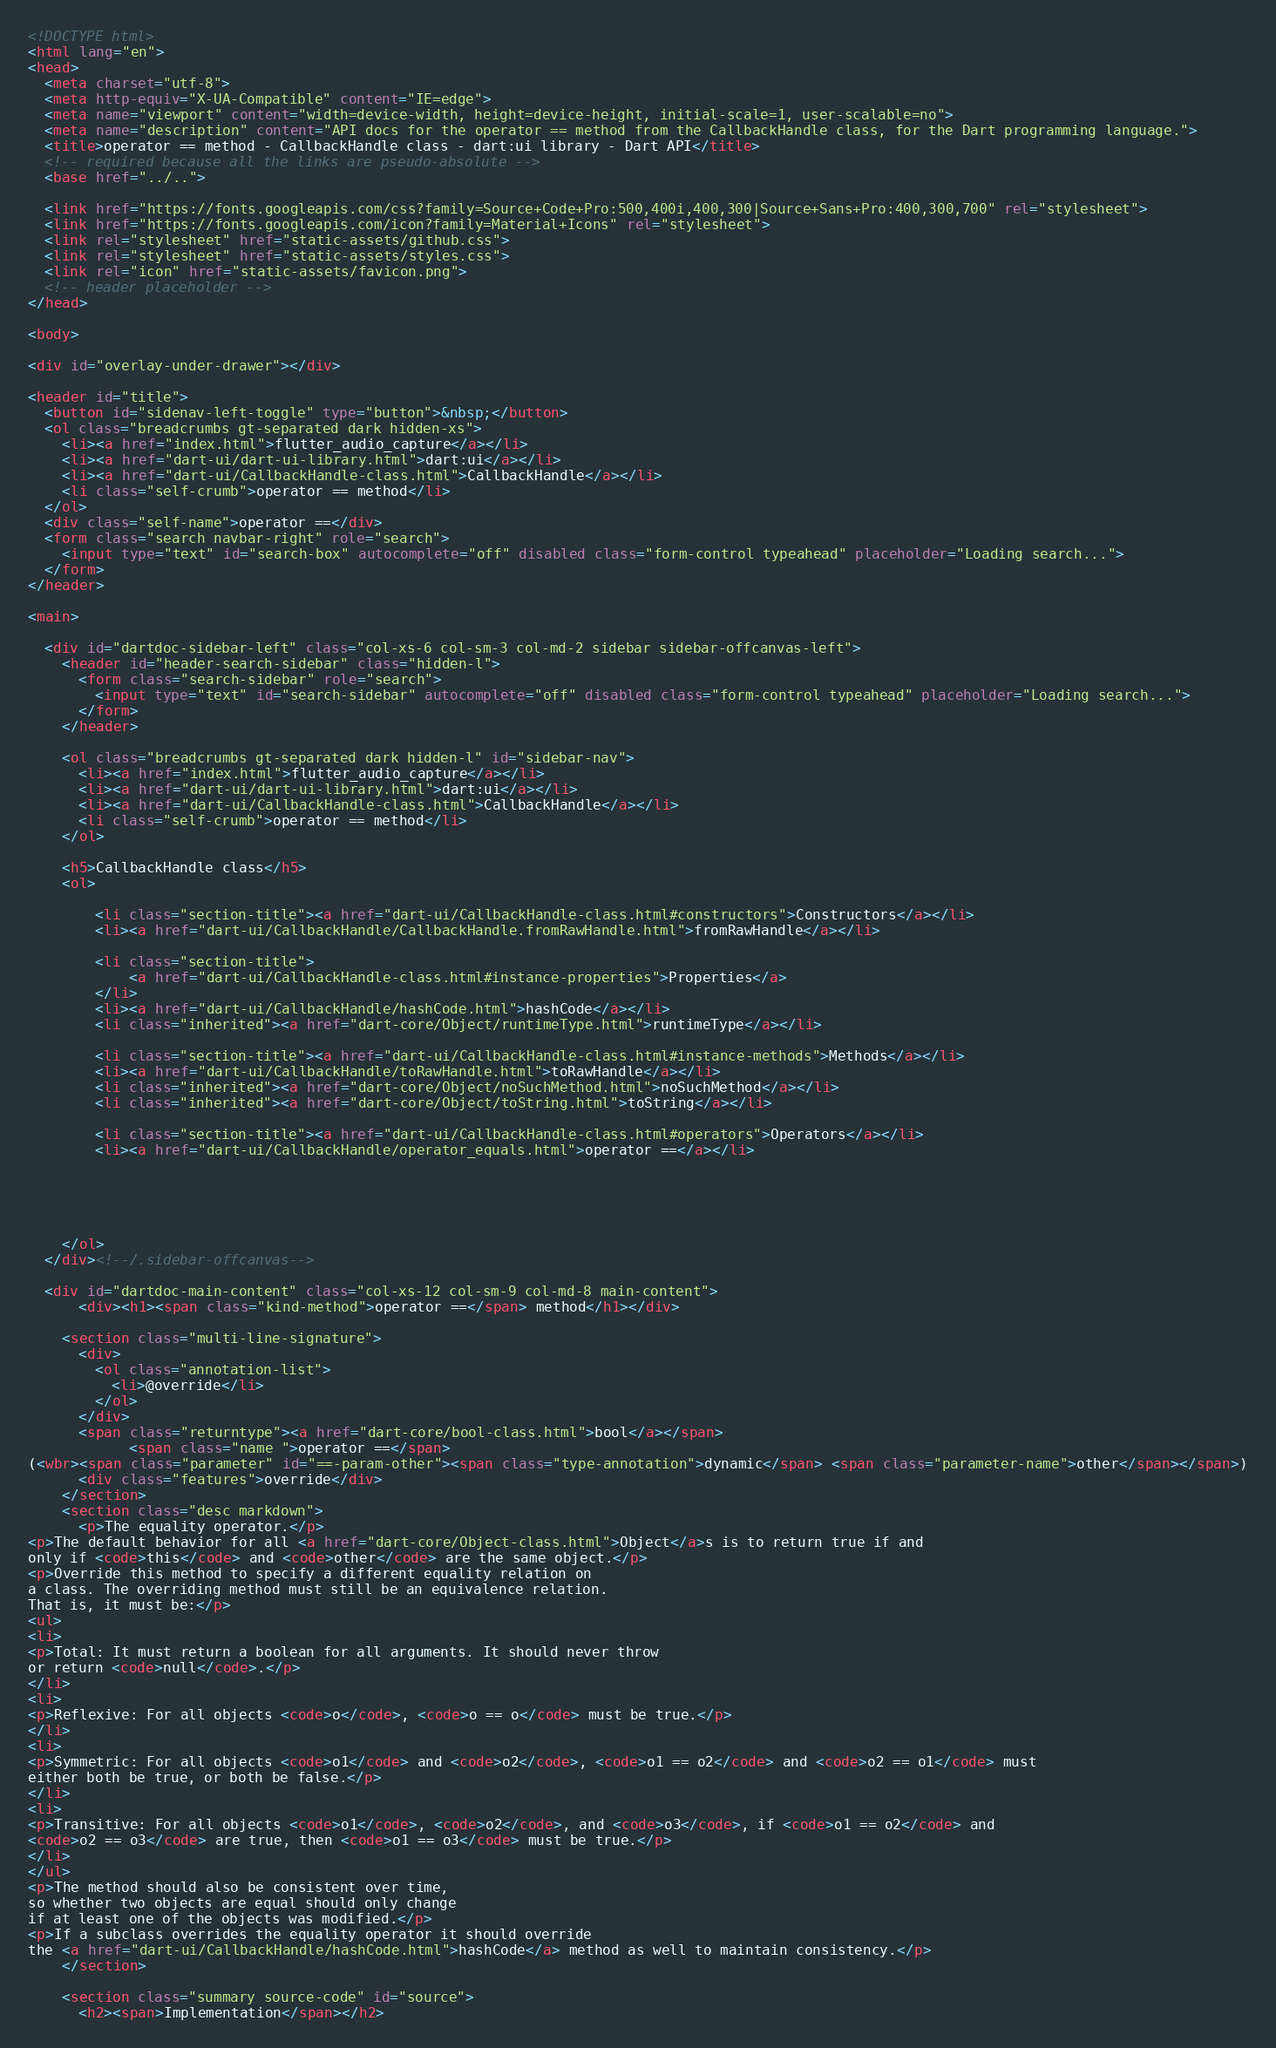<code> <loc_0><loc_0><loc_500><loc_500><_HTML_><!DOCTYPE html>
<html lang="en">
<head>
  <meta charset="utf-8">
  <meta http-equiv="X-UA-Compatible" content="IE=edge">
  <meta name="viewport" content="width=device-width, height=device-height, initial-scale=1, user-scalable=no">
  <meta name="description" content="API docs for the operator == method from the CallbackHandle class, for the Dart programming language.">
  <title>operator == method - CallbackHandle class - dart:ui library - Dart API</title>
  <!-- required because all the links are pseudo-absolute -->
  <base href="../..">

  <link href="https://fonts.googleapis.com/css?family=Source+Code+Pro:500,400i,400,300|Source+Sans+Pro:400,300,700" rel="stylesheet">
  <link href="https://fonts.googleapis.com/icon?family=Material+Icons" rel="stylesheet">
  <link rel="stylesheet" href="static-assets/github.css">
  <link rel="stylesheet" href="static-assets/styles.css">
  <link rel="icon" href="static-assets/favicon.png">
  <!-- header placeholder -->
</head>

<body>

<div id="overlay-under-drawer"></div>

<header id="title">
  <button id="sidenav-left-toggle" type="button">&nbsp;</button>
  <ol class="breadcrumbs gt-separated dark hidden-xs">
    <li><a href="index.html">flutter_audio_capture</a></li>
    <li><a href="dart-ui/dart-ui-library.html">dart:ui</a></li>
    <li><a href="dart-ui/CallbackHandle-class.html">CallbackHandle</a></li>
    <li class="self-crumb">operator == method</li>
  </ol>
  <div class="self-name">operator ==</div>
  <form class="search navbar-right" role="search">
    <input type="text" id="search-box" autocomplete="off" disabled class="form-control typeahead" placeholder="Loading search...">
  </form>
</header>

<main>

  <div id="dartdoc-sidebar-left" class="col-xs-6 col-sm-3 col-md-2 sidebar sidebar-offcanvas-left">
    <header id="header-search-sidebar" class="hidden-l">
      <form class="search-sidebar" role="search">
        <input type="text" id="search-sidebar" autocomplete="off" disabled class="form-control typeahead" placeholder="Loading search...">
      </form>
    </header>
    
    <ol class="breadcrumbs gt-separated dark hidden-l" id="sidebar-nav">
      <li><a href="index.html">flutter_audio_capture</a></li>
      <li><a href="dart-ui/dart-ui-library.html">dart:ui</a></li>
      <li><a href="dart-ui/CallbackHandle-class.html">CallbackHandle</a></li>
      <li class="self-crumb">operator == method</li>
    </ol>
    
    <h5>CallbackHandle class</h5>
    <ol>
    
        <li class="section-title"><a href="dart-ui/CallbackHandle-class.html#constructors">Constructors</a></li>
        <li><a href="dart-ui/CallbackHandle/CallbackHandle.fromRawHandle.html">fromRawHandle</a></li>
    
        <li class="section-title">
            <a href="dart-ui/CallbackHandle-class.html#instance-properties">Properties</a>
        </li>
        <li><a href="dart-ui/CallbackHandle/hashCode.html">hashCode</a></li>
        <li class="inherited"><a href="dart-core/Object/runtimeType.html">runtimeType</a></li>
    
        <li class="section-title"><a href="dart-ui/CallbackHandle-class.html#instance-methods">Methods</a></li>
        <li><a href="dart-ui/CallbackHandle/toRawHandle.html">toRawHandle</a></li>
        <li class="inherited"><a href="dart-core/Object/noSuchMethod.html">noSuchMethod</a></li>
        <li class="inherited"><a href="dart-core/Object/toString.html">toString</a></li>
    
        <li class="section-title"><a href="dart-ui/CallbackHandle-class.html#operators">Operators</a></li>
        <li><a href="dart-ui/CallbackHandle/operator_equals.html">operator ==</a></li>
    
    
    
    
    
    </ol>
  </div><!--/.sidebar-offcanvas-->

  <div id="dartdoc-main-content" class="col-xs-12 col-sm-9 col-md-8 main-content">
      <div><h1><span class="kind-method">operator ==</span> method</h1></div>

    <section class="multi-line-signature">
      <div>
        <ol class="annotation-list">
          <li>@override</li>
        </ol>
      </div>
      <span class="returntype"><a href="dart-core/bool-class.html">bool</a></span>
            <span class="name ">operator ==</span>
(<wbr><span class="parameter" id="==-param-other"><span class="type-annotation">dynamic</span> <span class="parameter-name">other</span></span>)
      <div class="features">override</div>
    </section>
    <section class="desc markdown">
      <p>The equality operator.</p>
<p>The default behavior for all <a href="dart-core/Object-class.html">Object</a>s is to return true if and
only if <code>this</code> and <code>other</code> are the same object.</p>
<p>Override this method to specify a different equality relation on
a class. The overriding method must still be an equivalence relation.
That is, it must be:</p>
<ul>
<li>
<p>Total: It must return a boolean for all arguments. It should never throw
or return <code>null</code>.</p>
</li>
<li>
<p>Reflexive: For all objects <code>o</code>, <code>o == o</code> must be true.</p>
</li>
<li>
<p>Symmetric: For all objects <code>o1</code> and <code>o2</code>, <code>o1 == o2</code> and <code>o2 == o1</code> must
either both be true, or both be false.</p>
</li>
<li>
<p>Transitive: For all objects <code>o1</code>, <code>o2</code>, and <code>o3</code>, if <code>o1 == o2</code> and
<code>o2 == o3</code> are true, then <code>o1 == o3</code> must be true.</p>
</li>
</ul>
<p>The method should also be consistent over time,
so whether two objects are equal should only change
if at least one of the objects was modified.</p>
<p>If a subclass overrides the equality operator it should override
the <a href="dart-ui/CallbackHandle/hashCode.html">hashCode</a> method as well to maintain consistency.</p>
    </section>
    
    <section class="summary source-code" id="source">
      <h2><span>Implementation</span></h2></code> 